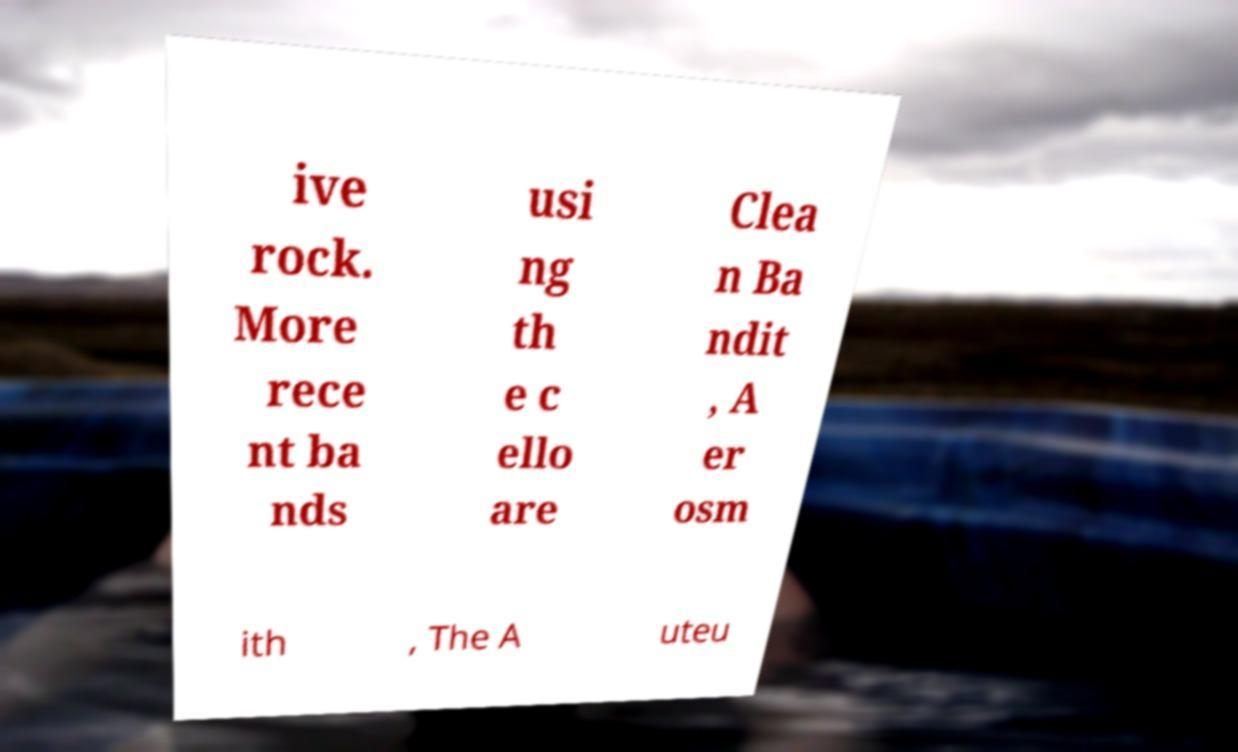Could you extract and type out the text from this image? ive rock. More rece nt ba nds usi ng th e c ello are Clea n Ba ndit , A er osm ith , The A uteu 